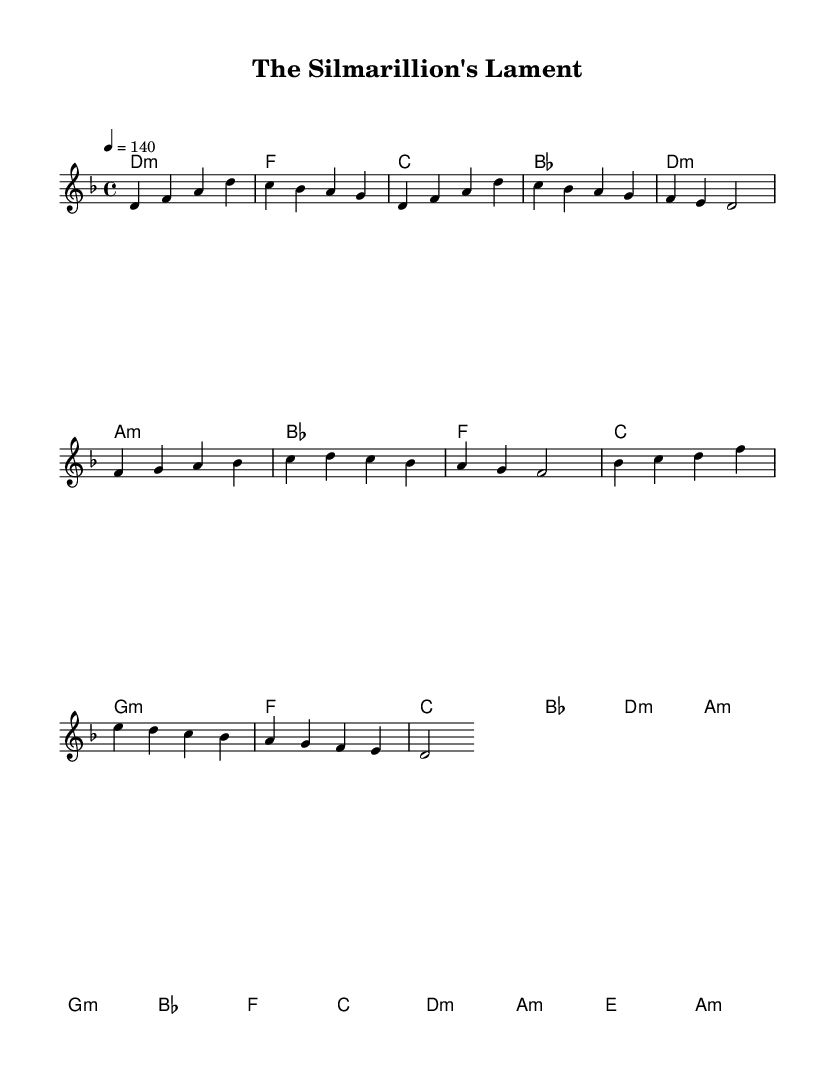What is the key signature of this music? The key signature is D minor, which has one flat (B flat). This can be identified by looking at the key signature indication at the beginning of the staff, where one flat is present, indicating the key of D minor.
Answer: D minor What is the time signature of this piece? The time signature is 4/4, which means there are four beats in a measure, and each quarter note gets one beat. This can be found at the beginning of the music, indicated right after the key signature.
Answer: 4/4 What is the tempo marking for this piece? The tempo marking is 140 beats per minute. This can be determined by looking at the tempo indication, which specifies the speed at which the piece should be played.
Answer: 140 How many measures are in the chorus section? There are six measures in the chorus section. By counting each measure within the section labeled chorus, which is distinctly separated from the other sections, we can determine the total number of measures present.
Answer: 6 Which note starts the bridge section? The bridge section starts with the note B flat. By examining the first note of the bridge, we can see that it is notated as the first note in this section and is directly followed by a series of notes within the bridge.
Answer: B flat What type of chord is the first chord in the introduction? The first chord in the introduction is a D minor chord. This can be identified from the chord names written above the staff, where the first chord is labeled as D:m, indicating it is a minor chord based on the root note D.
Answer: D minor What is the last chord of the piece? The last chord of the piece is A minor. This is found by looking at the chord names above the staff at the end of the music, where A minor is indicated as the final chord played.
Answer: A minor 